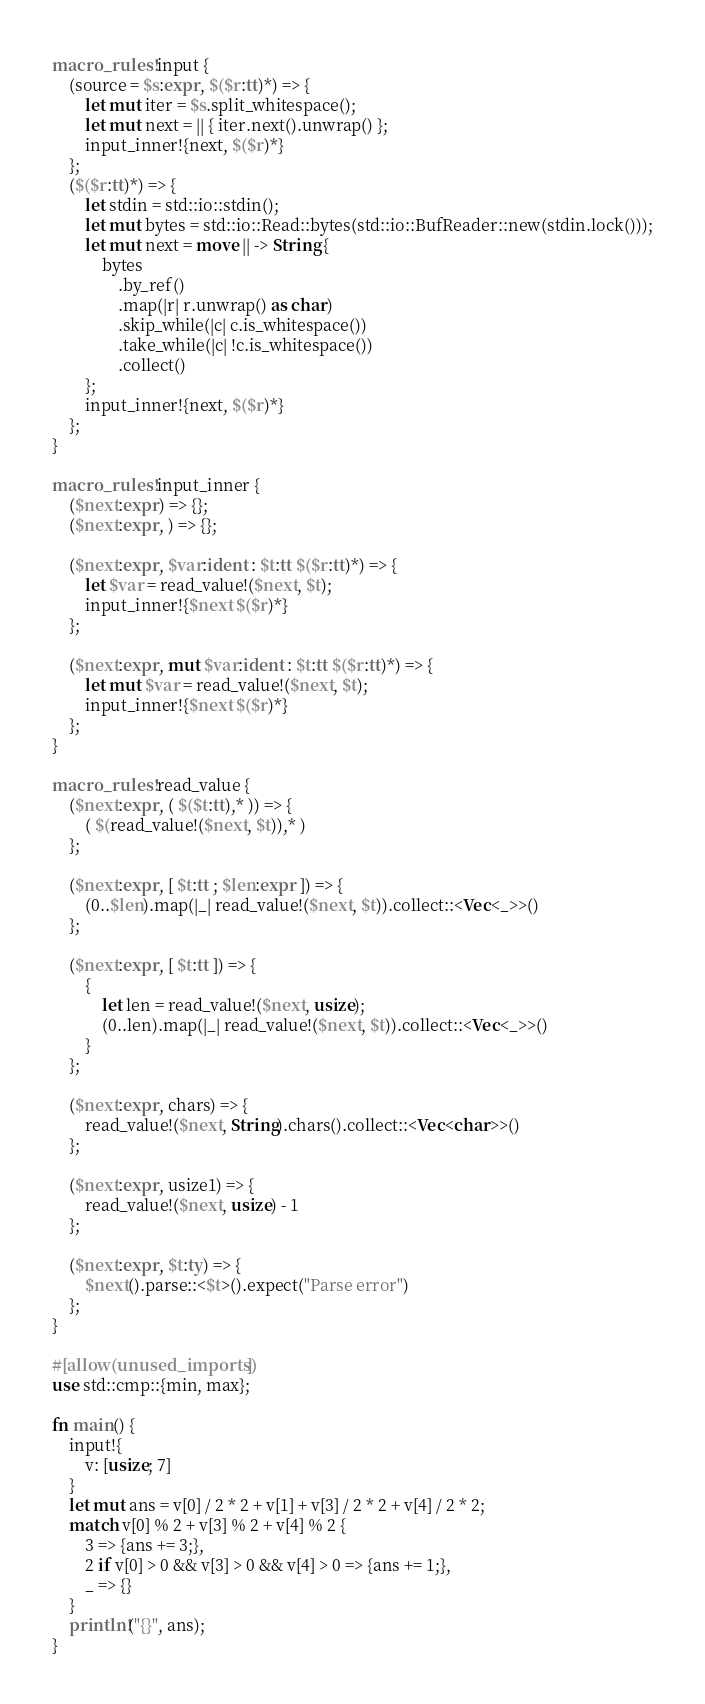<code> <loc_0><loc_0><loc_500><loc_500><_Rust_>macro_rules! input {
    (source = $s:expr, $($r:tt)*) => {
        let mut iter = $s.split_whitespace();
        let mut next = || { iter.next().unwrap() };
        input_inner!{next, $($r)*}
    };
    ($($r:tt)*) => {
        let stdin = std::io::stdin();
        let mut bytes = std::io::Read::bytes(std::io::BufReader::new(stdin.lock()));
        let mut next = move || -> String {
            bytes
                .by_ref()
                .map(|r| r.unwrap() as char)
                .skip_while(|c| c.is_whitespace())
                .take_while(|c| !c.is_whitespace())
                .collect()
        };
        input_inner!{next, $($r)*}
    };
}

macro_rules! input_inner {
    ($next:expr) => {};
    ($next:expr, ) => {};

    ($next:expr, $var:ident : $t:tt $($r:tt)*) => {
        let $var = read_value!($next, $t);
        input_inner!{$next $($r)*}
    };

    ($next:expr, mut $var:ident : $t:tt $($r:tt)*) => {
        let mut $var = read_value!($next, $t);
        input_inner!{$next $($r)*}
    };
}

macro_rules! read_value {
    ($next:expr, ( $($t:tt),* )) => {
        ( $(read_value!($next, $t)),* )
    };

    ($next:expr, [ $t:tt ; $len:expr ]) => {
        (0..$len).map(|_| read_value!($next, $t)).collect::<Vec<_>>()
    };

    ($next:expr, [ $t:tt ]) => {
        {
            let len = read_value!($next, usize);
            (0..len).map(|_| read_value!($next, $t)).collect::<Vec<_>>()
        }
    };

    ($next:expr, chars) => {
        read_value!($next, String).chars().collect::<Vec<char>>()
    };

    ($next:expr, usize1) => {
        read_value!($next, usize) - 1
    };

    ($next:expr, $t:ty) => {
        $next().parse::<$t>().expect("Parse error")
    };
}

#[allow(unused_imports)]
use std::cmp::{min, max};

fn main() {
    input!{
        v: [usize; 7]
    }
    let mut ans = v[0] / 2 * 2 + v[1] + v[3] / 2 * 2 + v[4] / 2 * 2;
    match v[0] % 2 + v[3] % 2 + v[4] % 2 {
        3 => {ans += 3;},
        2 if v[0] > 0 && v[3] > 0 && v[4] > 0 => {ans += 1;},
        _ => {}
    }
    println!("{}", ans);
}
</code> 